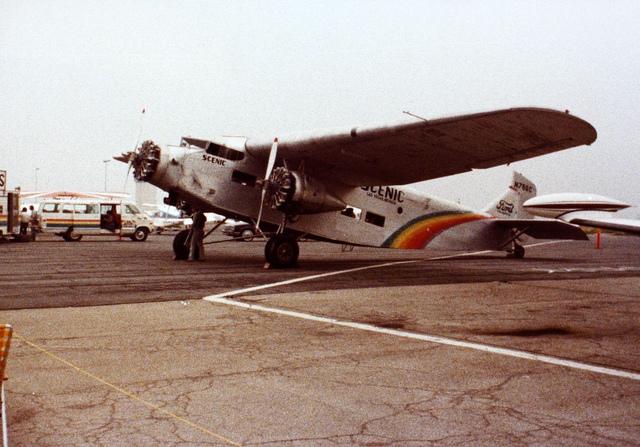Is the plane in motion?
Keep it brief. No. What number is the plane?
Quick response, please. 5. How many wheels on the plane?
Keep it brief. 3. What points to this being an older picture?
Quick response, please. Color. What is the number on the front of the plane?
Concise answer only. Unknown. How many propellers does the airplane have?
Write a very short answer. 2. Is the plane new?
Concise answer only. No. 